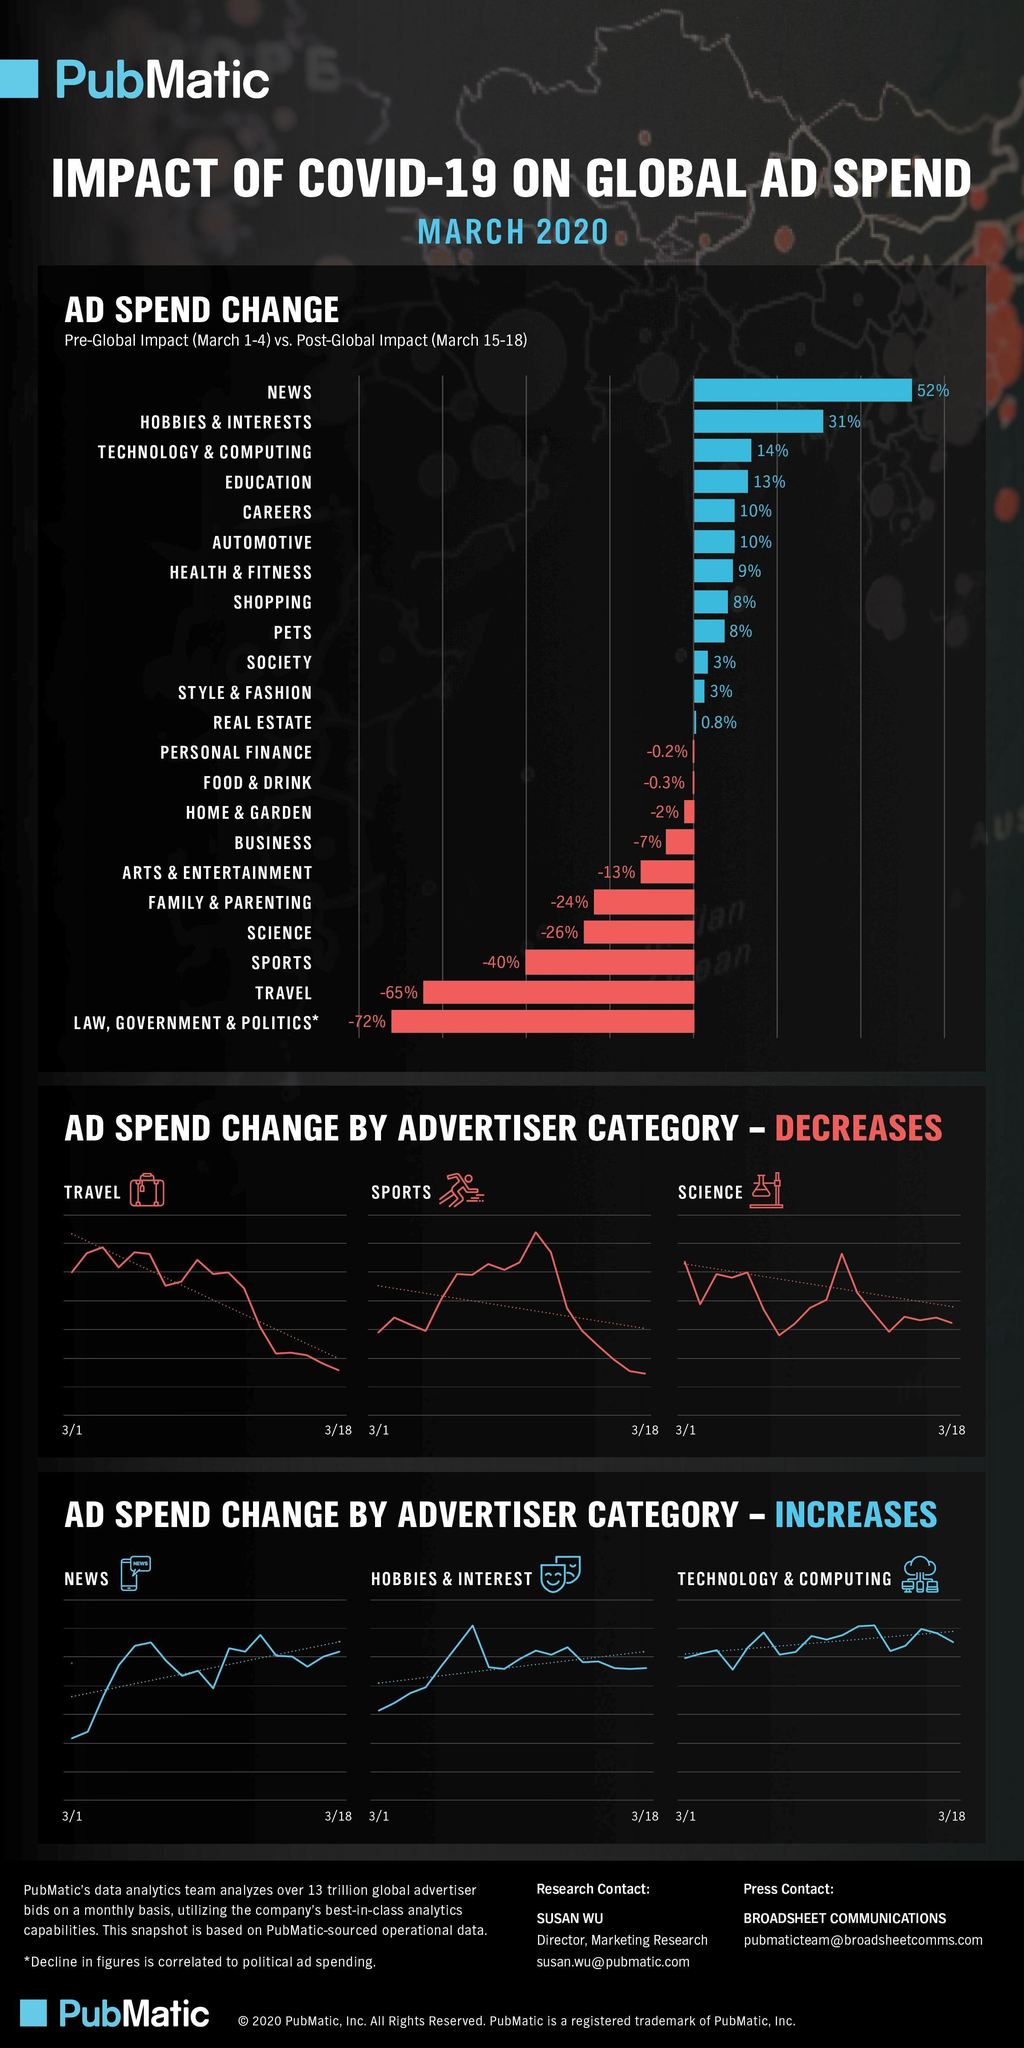In the bar graph which sector has the second highest % reduction in ad spend?
Answer the question with a short phrase. travel Which is the third category shown where ad spend by advertiser has decreased? science In the bar graph which sector has the third highest % increase in ad spend? technology & computing Which is the second category shown where ad spend by advertiser has increased? hobbies & interest How many sectors show an increase of 25% or above in ad spending? 2 In the bar graph which sector has the lowest % increase in ad spend? real estate How many sectors are shown in the bar graph where the ad spend has decreased by 25% or more? 4 In the bar graph which sector has the second lowest % reduction in ad spend? Food & drink 